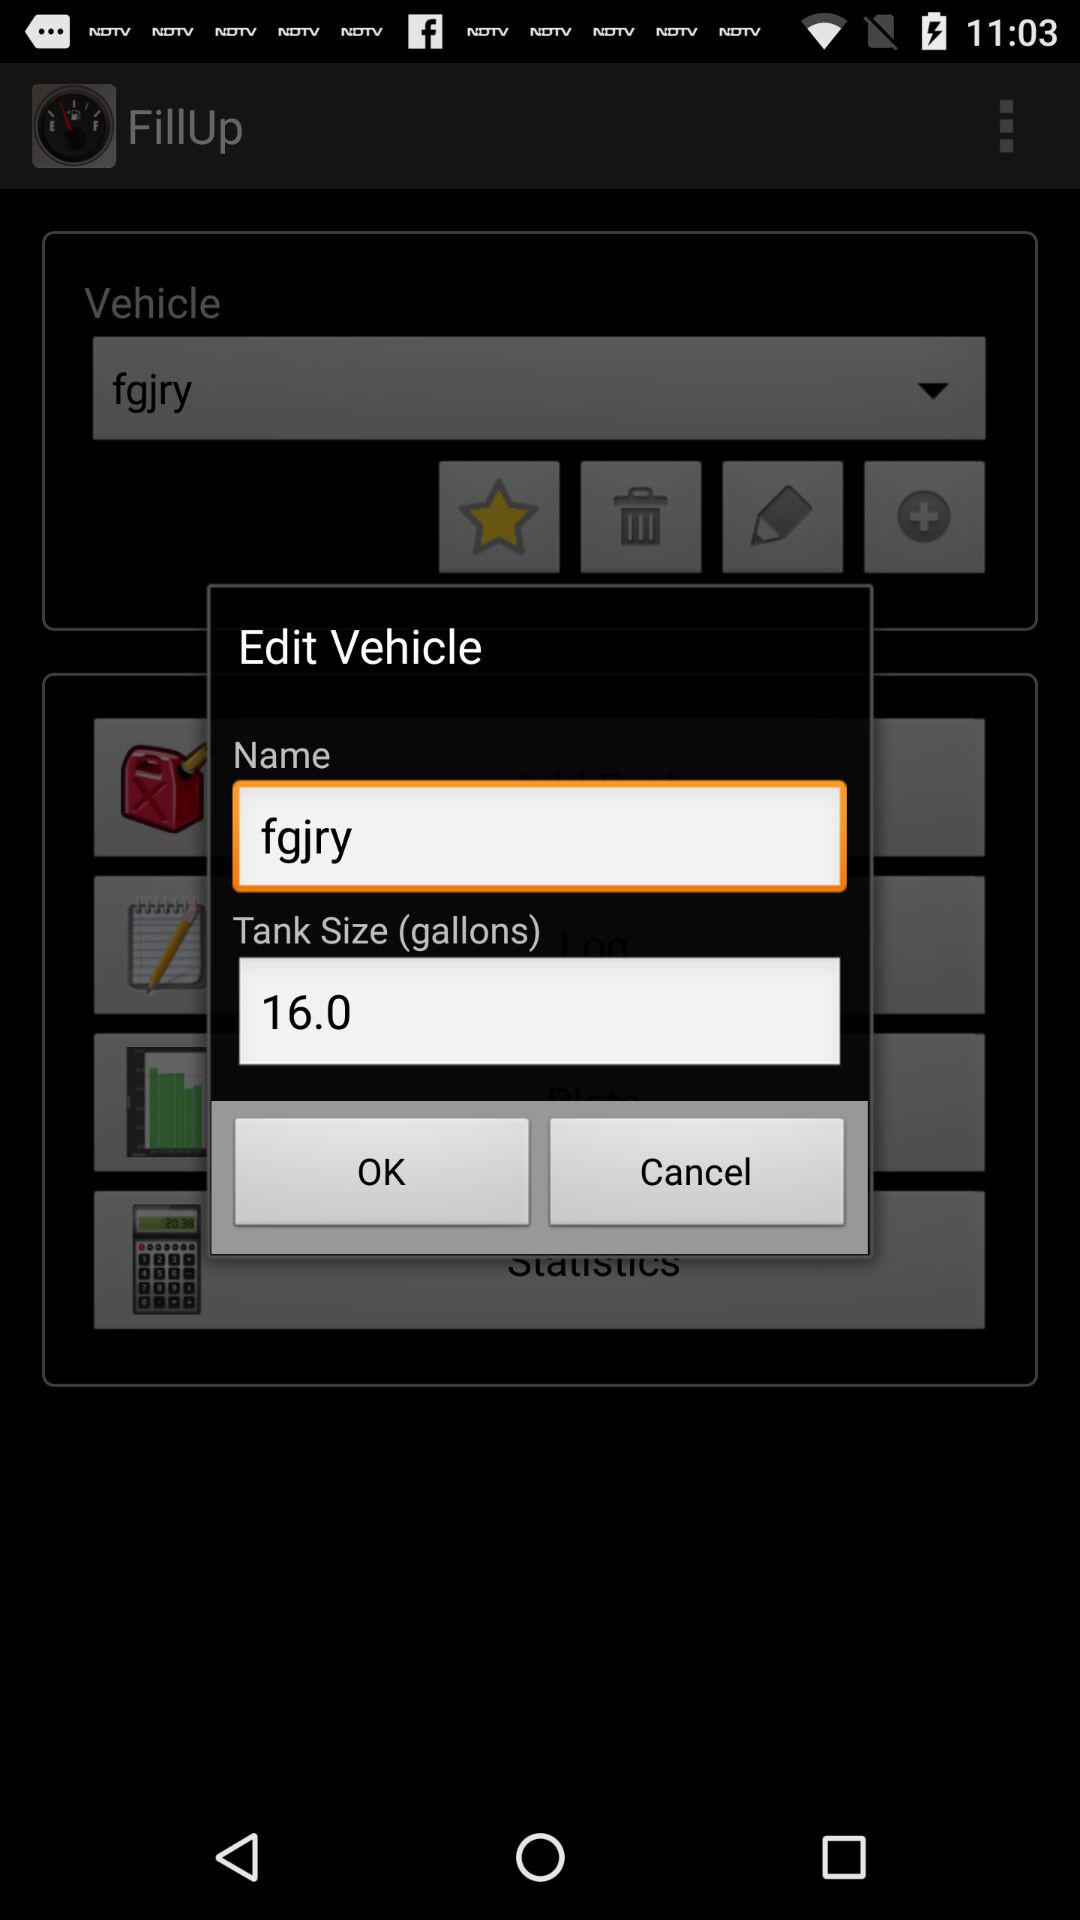What is the tank size? The tank size is 16.0 gallons. 